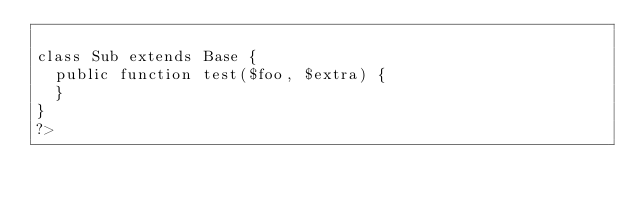Convert code to text. <code><loc_0><loc_0><loc_500><loc_500><_PHP_>
class Sub extends Base {
	public function test($foo, $extra) {
	}	
}
?>
</code> 